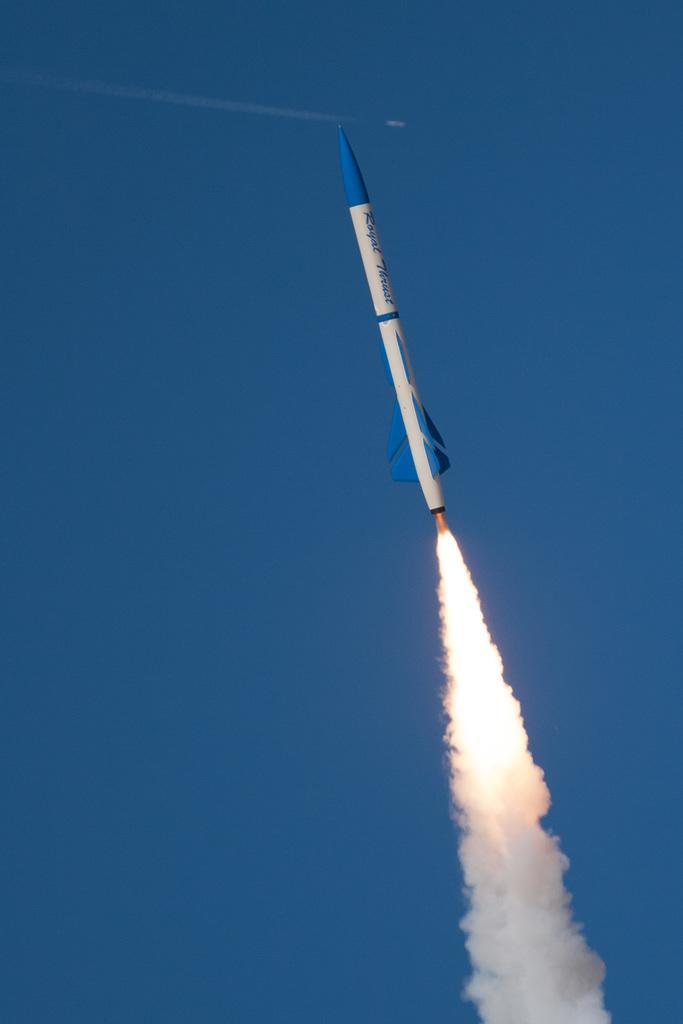In one or two sentences, can you explain what this image depicts? In this picture there is a rocket which is going up. At the bottom we can see smoke which is coming from the rocket. On the left there is a sky. 